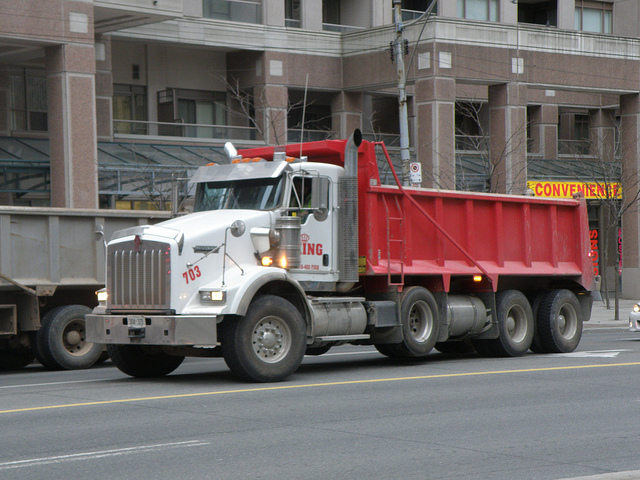Please extract the text content from this image. 703 ING CONVENIENCE 